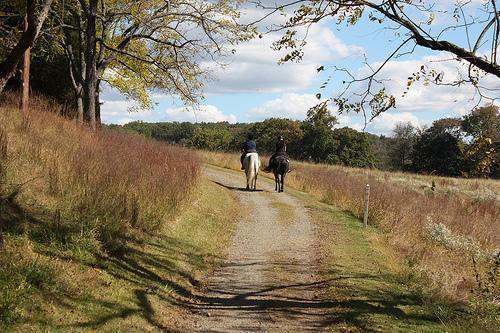How many horses are present?
Give a very brief answer. 2. 